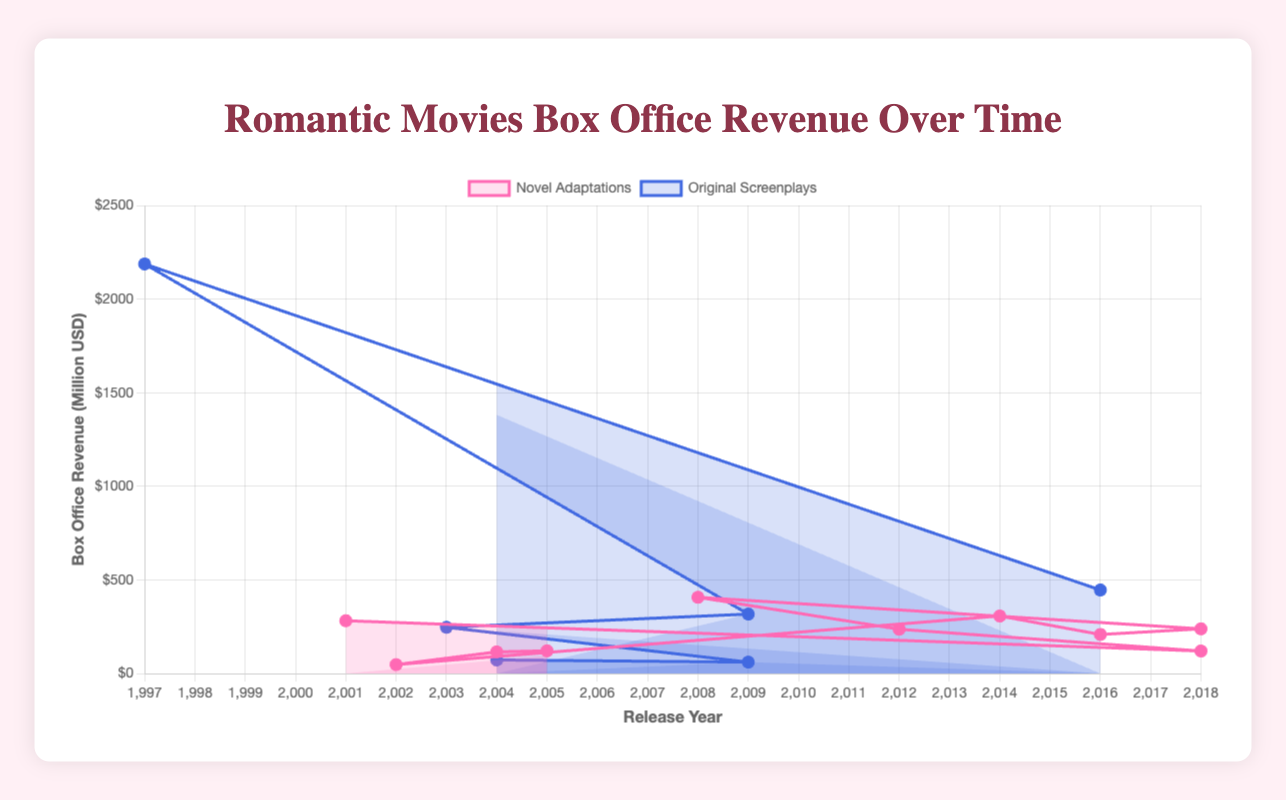Which type of romantic movie generated the most box office revenue? By examining the plot, we can see the highest peak on the graph represents "Titanic," an original screenplay. Thus, original screenplays have the highest box office revenue.
Answer: Original Screenplays Which movie has the highest box office revenue among novel adaptations? Looking at the visual data points for novel adaptations, the highest peak corresponds to the movie "Twilight."
Answer: Twilight What's the total box office revenue for all romantic movies adapted from novels released in 2018? Sum the revenues of all novel adaptations released in 2018: "Crazy Rich Asians" ($238.5M) and "To All the Boys I've Loved Before" ($120.0M). The total is $238.5M + $120.0M = $358.5M.
Answer: $358.5M How do box office revenues for romantic movies adapted from novels and original screenplays compare in 2016? Compare the data points for 2016: "Me Before You" (Novels: $208.3M) and "La La Land" (Original Screenplays: $446.1M).
Answer: Original Screenplays have higher revenue in 2016 Which source of romantic movies (Novel vs. Original Screenplay) showed the most consistency in box office revenue over time? Examining both datasets, original screenplays exhibit wider revenue variations due to the large gap between movies like "Titanic" and lower-grossing films. On the other hand, novels show a more consistent and moderate range.
Answer: Novels What is the average box office revenue for novel adaptations released in or after 2012? The movies are "The Fault in Our Stars" ($307.2M), "Me Before You" ($208.3M), "Crazy Rich Asians" ($238.5M), "To All the Boys I've Loved Before" ($120.0M), and "Silver Linings Playbook" ($236.4M). Calculate the average: ($307.2M + $208.3M + $238.5M + $120.0M + $236.4M) / 5 = $222.08M.
Answer: $222.08M Which movie from an original screenplay released between 2000 and 2010 has the lowest box office revenue? Focus on the original screenplays in this range: "Love Actually" ($246.8M), "The Proposal" ($317.4M), and "500 Days of Summer" ($60.7M). The lowest revenue is "500 Days of Summer."
Answer: 500 Days of Summer Is there a trend in box office revenue for romantic movies adapted from novels over time? The visual line plot for novel adaptations shows an upward trend over time, with increasing boxes each year except for minor drops.
Answer: Upward Trend 